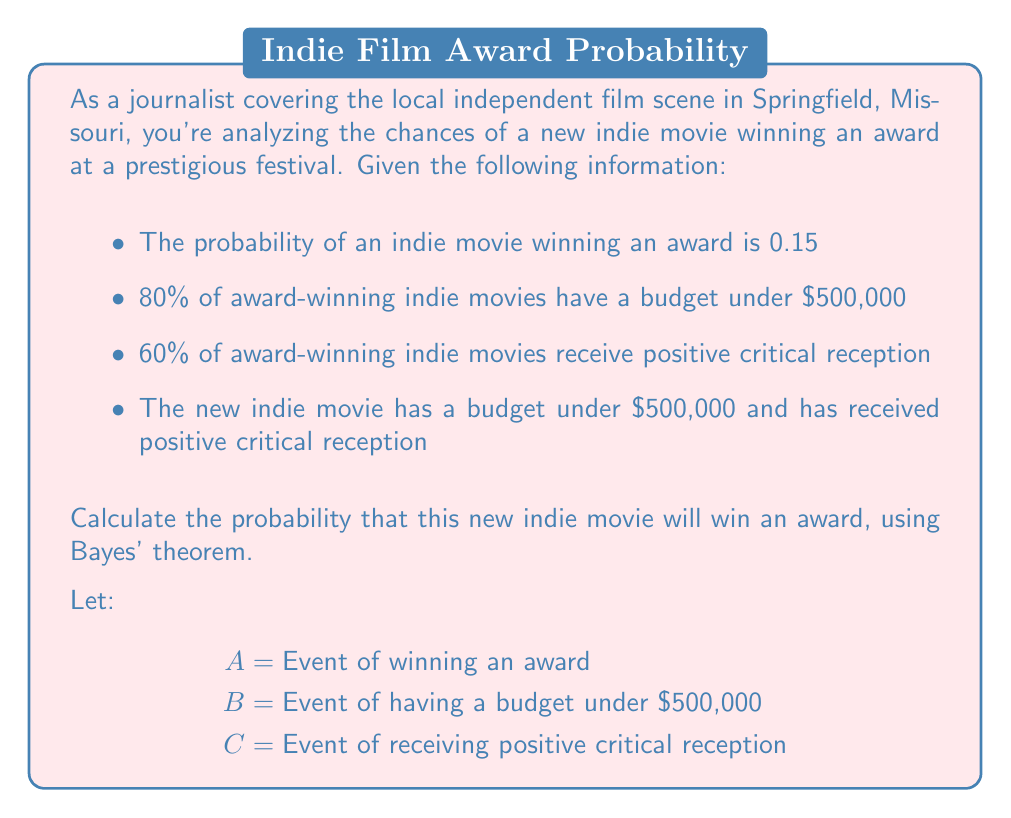Solve this math problem. To solve this problem, we'll use Bayes' theorem and the given information. Let's break it down step-by-step:

1. Given probabilities:
   $P(A) = 0.15$ (probability of winning an award)
   $P(B|A) = 0.80$ (probability of budget under $500,000 given award win)
   $P(C|A) = 0.60$ (probability of positive reception given award win)

2. We need to find $P(A|B \cap C)$ using Bayes' theorem:

   $$P(A|B \cap C) = \frac{P(B \cap C|A) \cdot P(A)}{P(B \cap C)}$$

3. Assuming B and C are independent given A:
   $P(B \cap C|A) = P(B|A) \cdot P(C|A) = 0.80 \cdot 0.60 = 0.48$

4. We can calculate $P(B \cap C)$ using the law of total probability:
   $$P(B \cap C) = P(B \cap C|A) \cdot P(A) + P(B \cap C|\neg A) \cdot P(\neg A)$$

5. We need to estimate $P(B \cap C|\neg A)$. Let's assume it's lower than $P(B \cap C|A)$, say 0.30.

6. Now we can calculate $P(B \cap C)$:
   $$P(B \cap C) = 0.48 \cdot 0.15 + 0.30 \cdot 0.85 = 0.072 + 0.255 = 0.327$$

7. Plugging everything into Bayes' theorem:

   $$P(A|B \cap C) = \frac{0.48 \cdot 0.15}{0.327} \approx 0.2202$$

8. Converting to a percentage: 0.2202 * 100 ≈ 22.02%
Answer: 22.02% 